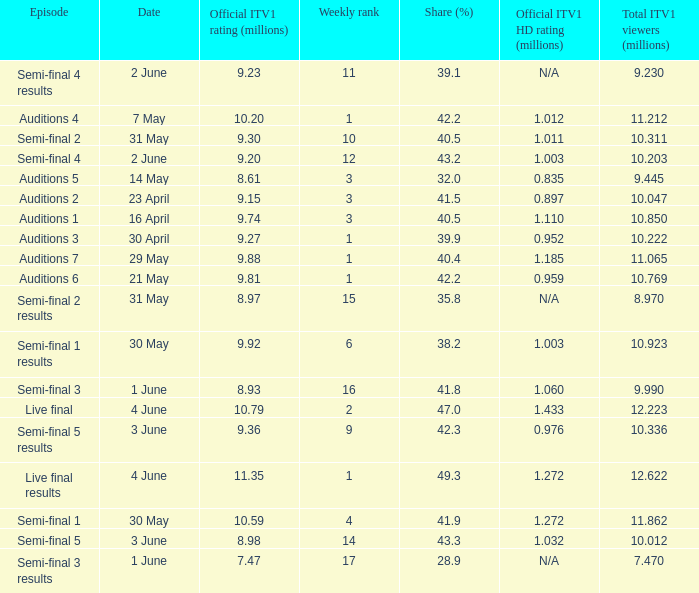When was the episode that had a share (%) of 41.5? 23 April. 